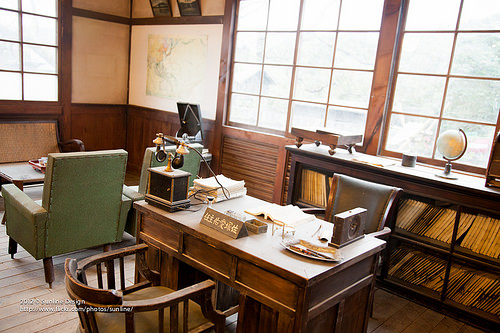<image>
Is the phone on the table? Yes. Looking at the image, I can see the phone is positioned on top of the table, with the table providing support. Is there a globe on the window pane? No. The globe is not positioned on the window pane. They may be near each other, but the globe is not supported by or resting on top of the window pane. 